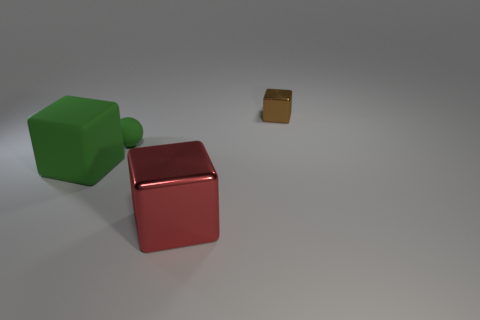Add 1 yellow rubber cylinders. How many objects exist? 5 Subtract all balls. How many objects are left? 3 Subtract all tiny green cubes. Subtract all red blocks. How many objects are left? 3 Add 3 brown things. How many brown things are left? 4 Add 1 green metallic spheres. How many green metallic spheres exist? 1 Subtract 0 yellow blocks. How many objects are left? 4 